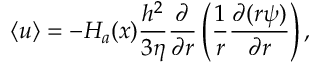<formula> <loc_0><loc_0><loc_500><loc_500>\left \langle u \right \rangle = - H _ { a } ( x ) \frac { h ^ { 2 } } { 3 \eta } \frac { \partial } { \partial r } \left ( \frac { 1 } { r } \frac { \partial ( r \psi ) } { \partial r } \right ) ,</formula> 